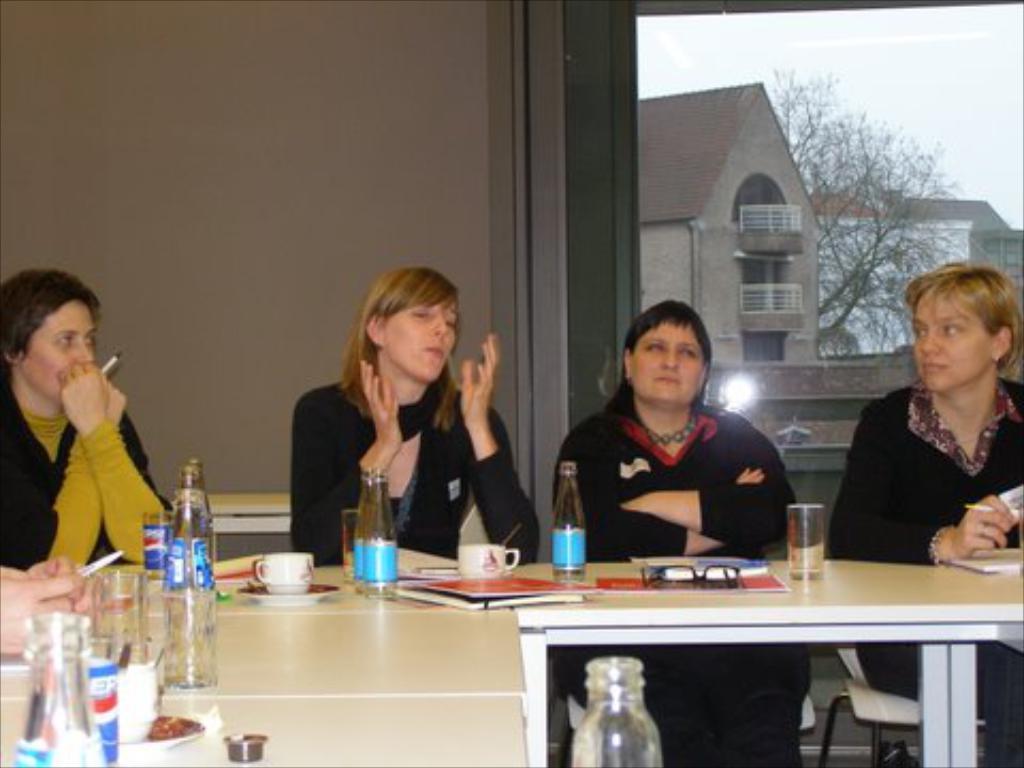Can you describe this image briefly? There are four members sitting in front of a table. Four of them were women. On the table there is a cup, bottles and glasses. There are some papers too. In the background, from the window we can observe some houses, trees and sky here. 